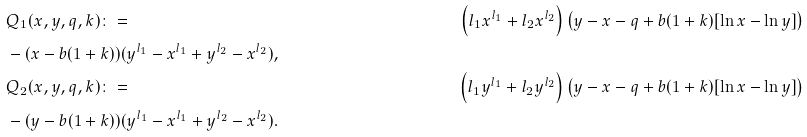<formula> <loc_0><loc_0><loc_500><loc_500>& Q _ { 1 } ( x , y , q , k ) \colon = & \left ( l _ { 1 } x ^ { l _ { 1 } } + l _ { 2 } x ^ { l _ { 2 } } \right ) \left ( y - x - q + b ( 1 + k ) [ \ln { x } - \ln { y } ] \right ) \\ & - ( x - b ( 1 + k ) ) ( y ^ { l _ { 1 } } - x ^ { l _ { 1 } } + y ^ { l _ { 2 } } - x ^ { l _ { 2 } } ) , \\ & Q _ { 2 } ( x , y , q , k ) \colon = & \left ( l _ { 1 } y ^ { l _ { 1 } } + l _ { 2 } y ^ { l _ { 2 } } \right ) \left ( y - x - q + b ( 1 + k ) [ \ln { x } - \ln { y } ] \right ) \\ & - ( y - b ( 1 + k ) ) ( y ^ { l _ { 1 } } - x ^ { l _ { 1 } } + y ^ { l _ { 2 } } - x ^ { l _ { 2 } } ) .</formula> 